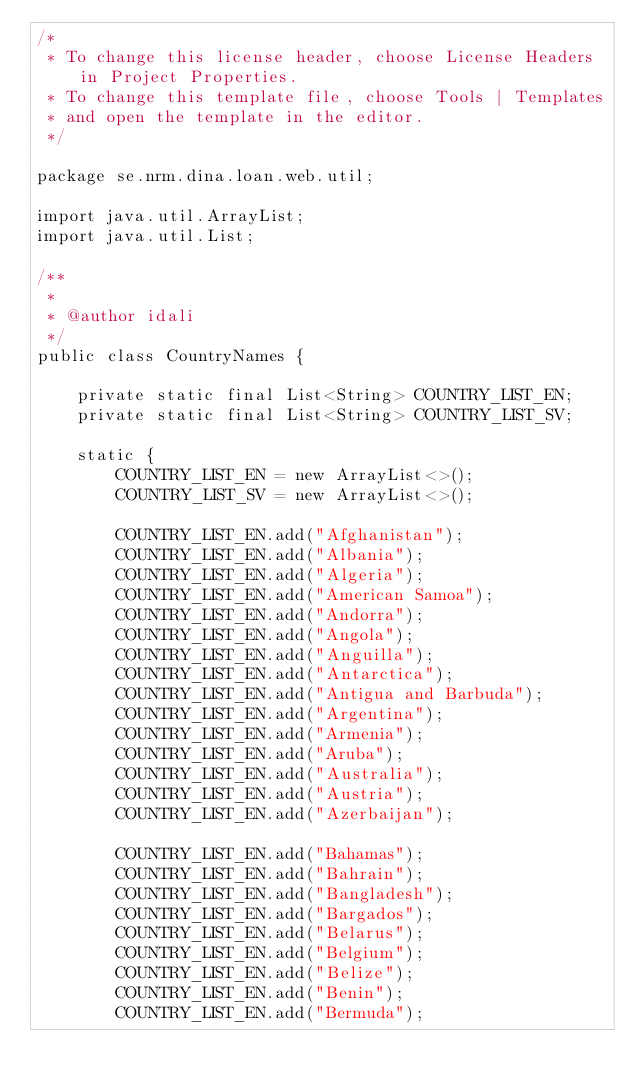Convert code to text. <code><loc_0><loc_0><loc_500><loc_500><_Java_>/*
 * To change this license header, choose License Headers in Project Properties.
 * To change this template file, choose Tools | Templates
 * and open the template in the editor.
 */

package se.nrm.dina.loan.web.util;

import java.util.ArrayList;
import java.util.List;

/**
 *
 * @author idali
 */
public class CountryNames {
    
    private static final List<String> COUNTRY_LIST_EN;
    private static final List<String> COUNTRY_LIST_SV;
    
    static {
        COUNTRY_LIST_EN = new ArrayList<>();
        COUNTRY_LIST_SV = new ArrayList<>();
         
        COUNTRY_LIST_EN.add("Afghanistan");
        COUNTRY_LIST_EN.add("Albania");
        COUNTRY_LIST_EN.add("Algeria");
        COUNTRY_LIST_EN.add("American Samoa");
        COUNTRY_LIST_EN.add("Andorra");
        COUNTRY_LIST_EN.add("Angola");
        COUNTRY_LIST_EN.add("Anguilla");
        COUNTRY_LIST_EN.add("Antarctica"); 
        COUNTRY_LIST_EN.add("Antigua and Barbuda");
        COUNTRY_LIST_EN.add("Argentina");
        COUNTRY_LIST_EN.add("Armenia");
        COUNTRY_LIST_EN.add("Aruba");
        COUNTRY_LIST_EN.add("Australia");
        COUNTRY_LIST_EN.add("Austria");
        COUNTRY_LIST_EN.add("Azerbaijan");
         
        COUNTRY_LIST_EN.add("Bahamas");
        COUNTRY_LIST_EN.add("Bahrain");
        COUNTRY_LIST_EN.add("Bangladesh");
        COUNTRY_LIST_EN.add("Bargados");
        COUNTRY_LIST_EN.add("Belarus");
        COUNTRY_LIST_EN.add("Belgium");
        COUNTRY_LIST_EN.add("Belize");
        COUNTRY_LIST_EN.add("Benin");
        COUNTRY_LIST_EN.add("Bermuda"); </code> 